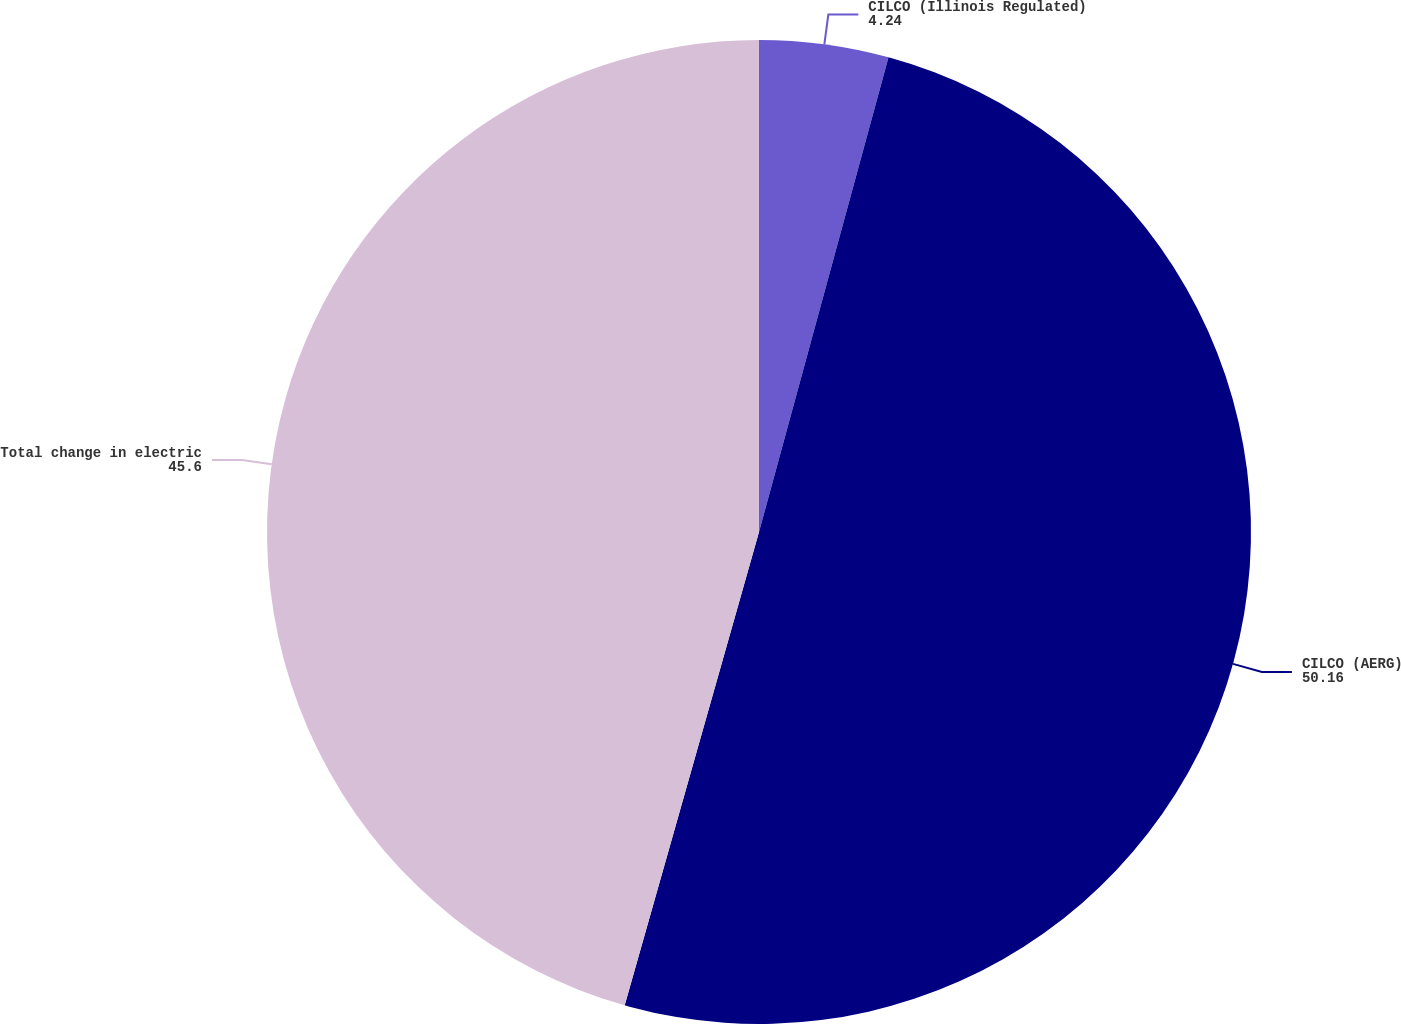<chart> <loc_0><loc_0><loc_500><loc_500><pie_chart><fcel>CILCO (Illinois Regulated)<fcel>CILCO (AERG)<fcel>Total change in electric<nl><fcel>4.24%<fcel>50.16%<fcel>45.6%<nl></chart> 